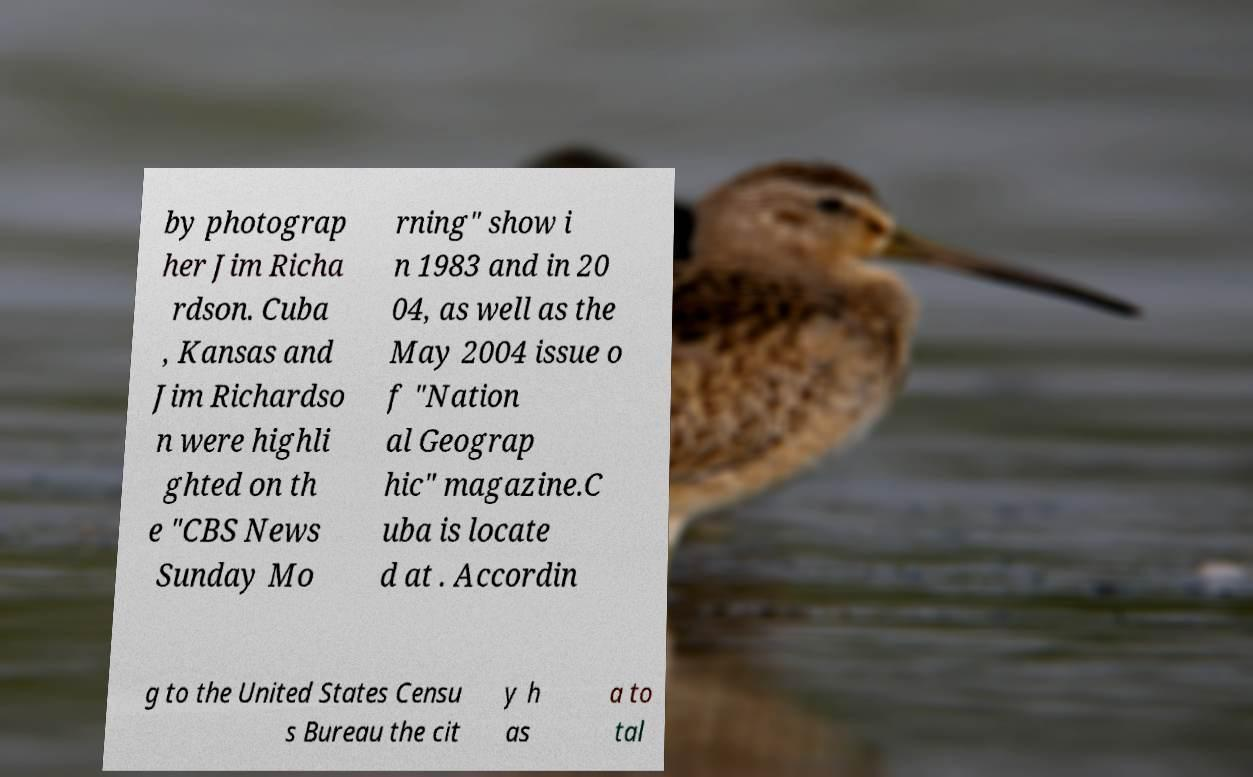Could you extract and type out the text from this image? by photograp her Jim Richa rdson. Cuba , Kansas and Jim Richardso n were highli ghted on th e "CBS News Sunday Mo rning" show i n 1983 and in 20 04, as well as the May 2004 issue o f "Nation al Geograp hic" magazine.C uba is locate d at . Accordin g to the United States Censu s Bureau the cit y h as a to tal 